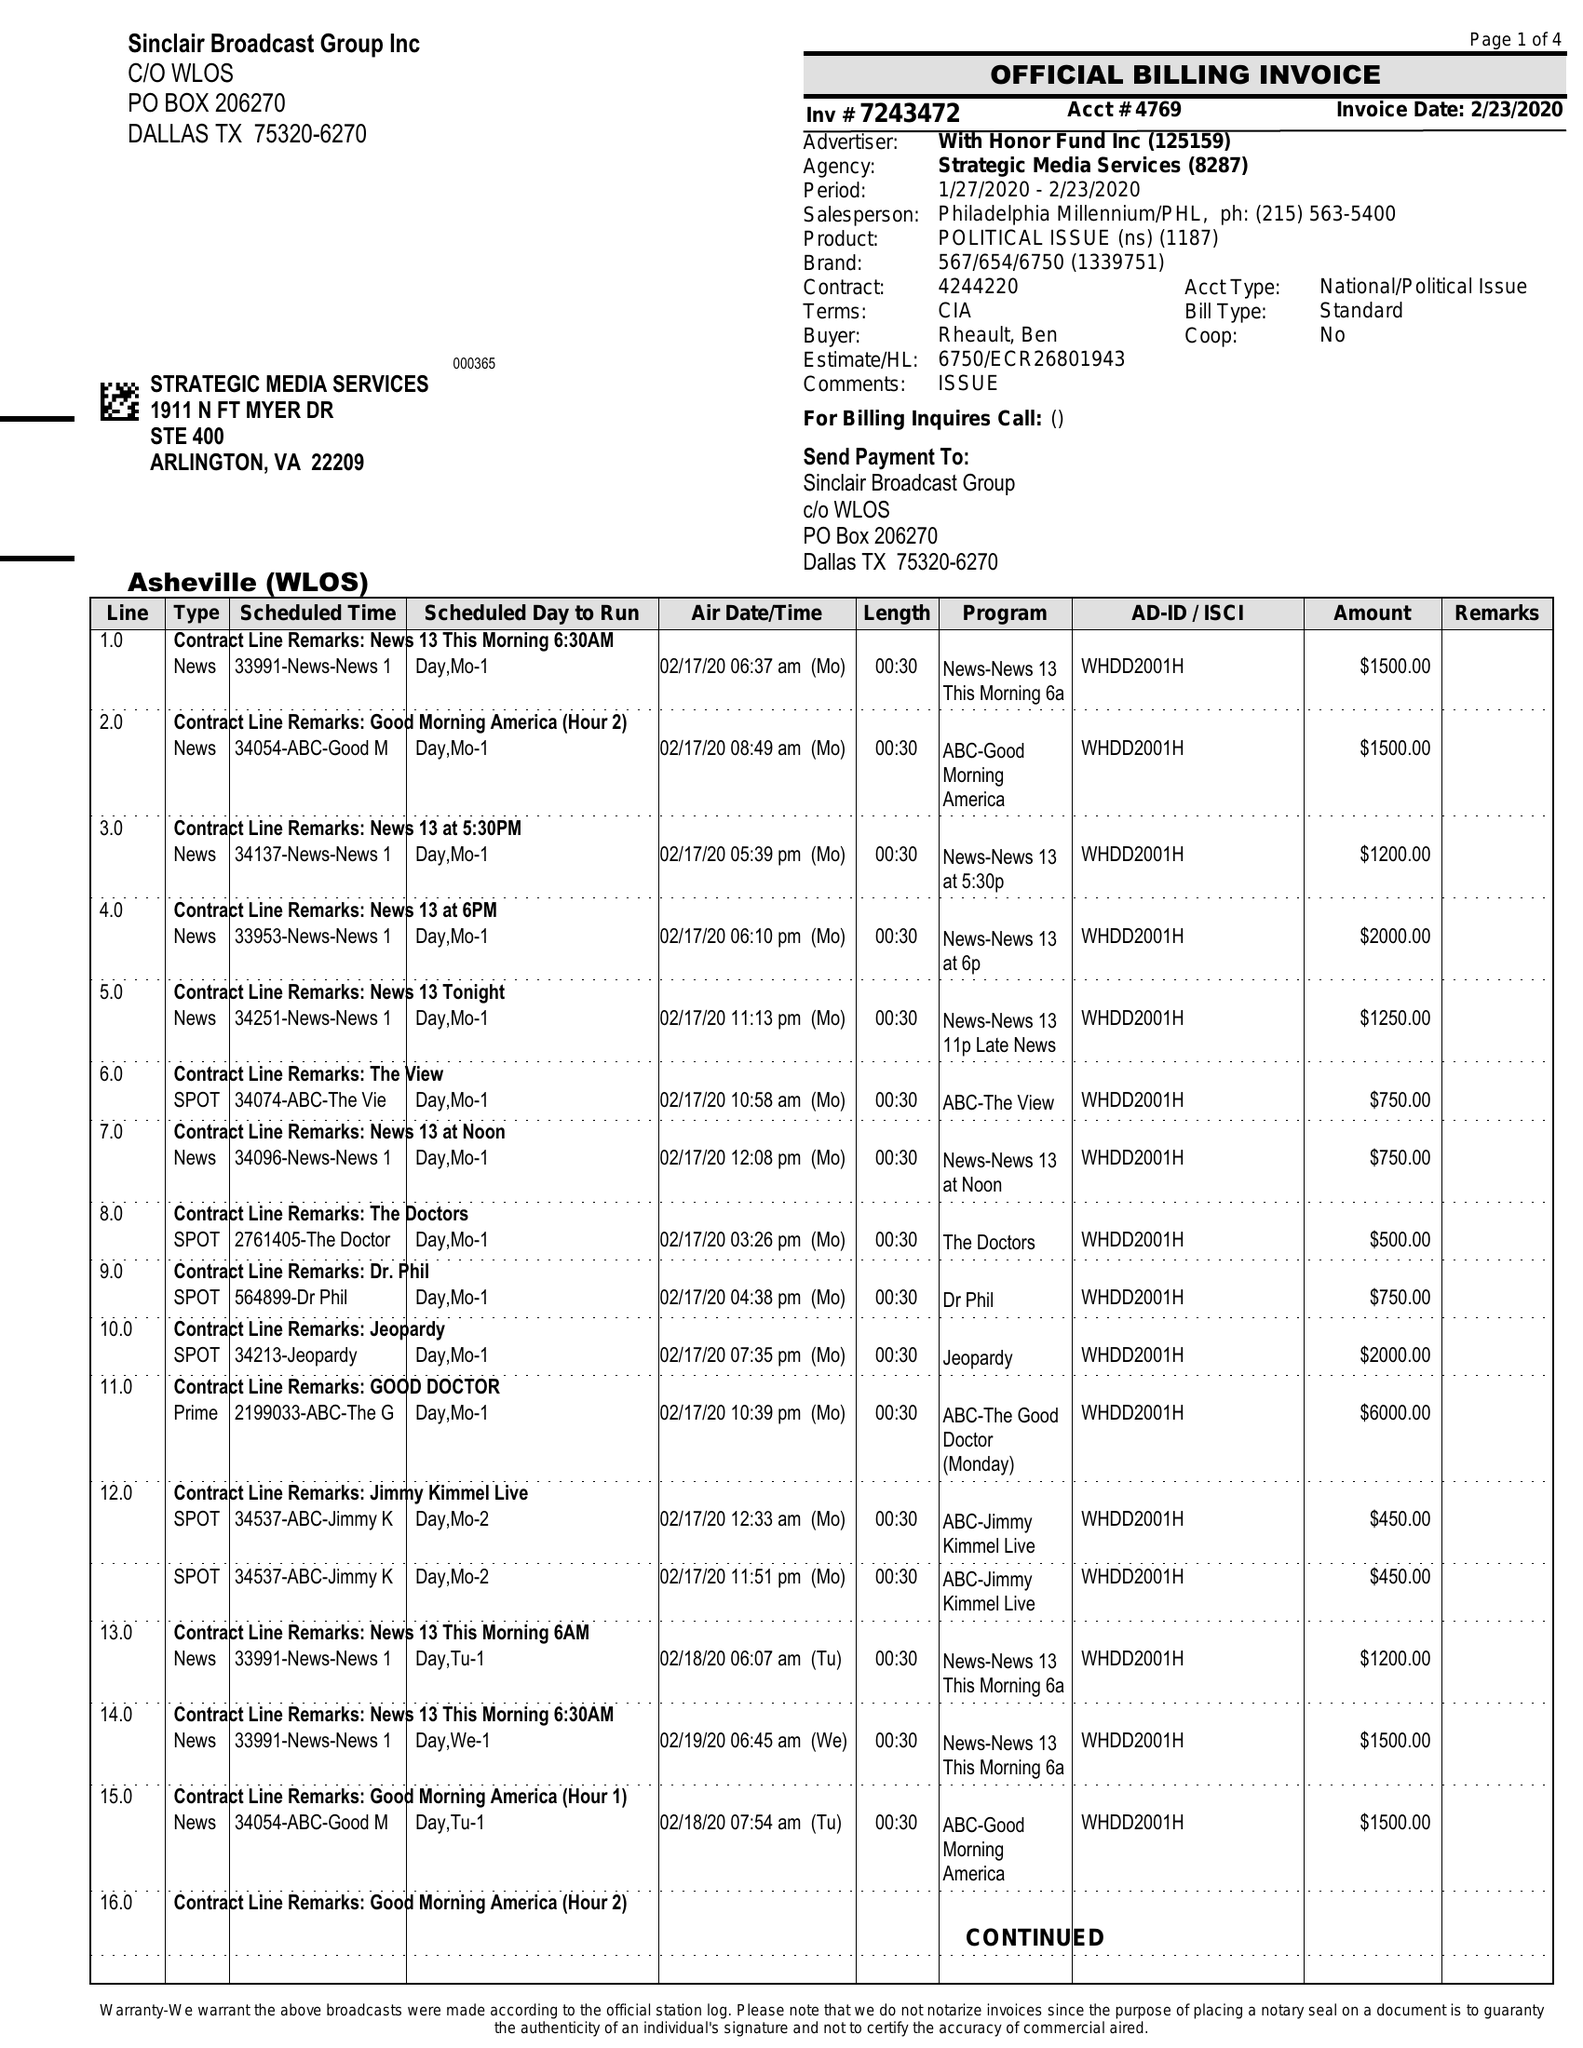What is the value for the contract_num?
Answer the question using a single word or phrase. 7243472 